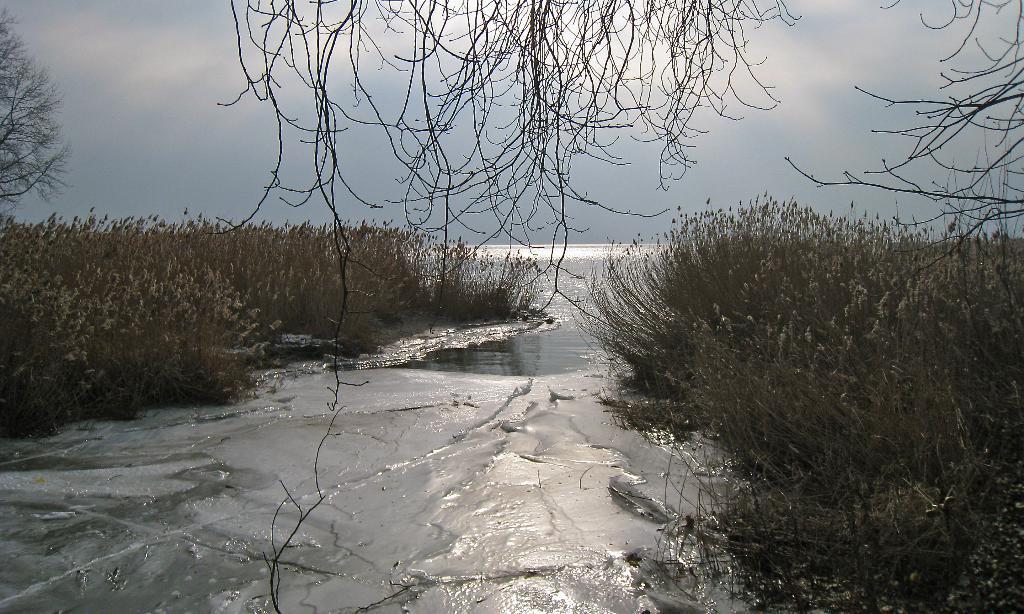Can you describe this image briefly? Here we can see water, plants, and trees. In the background there is sky. 